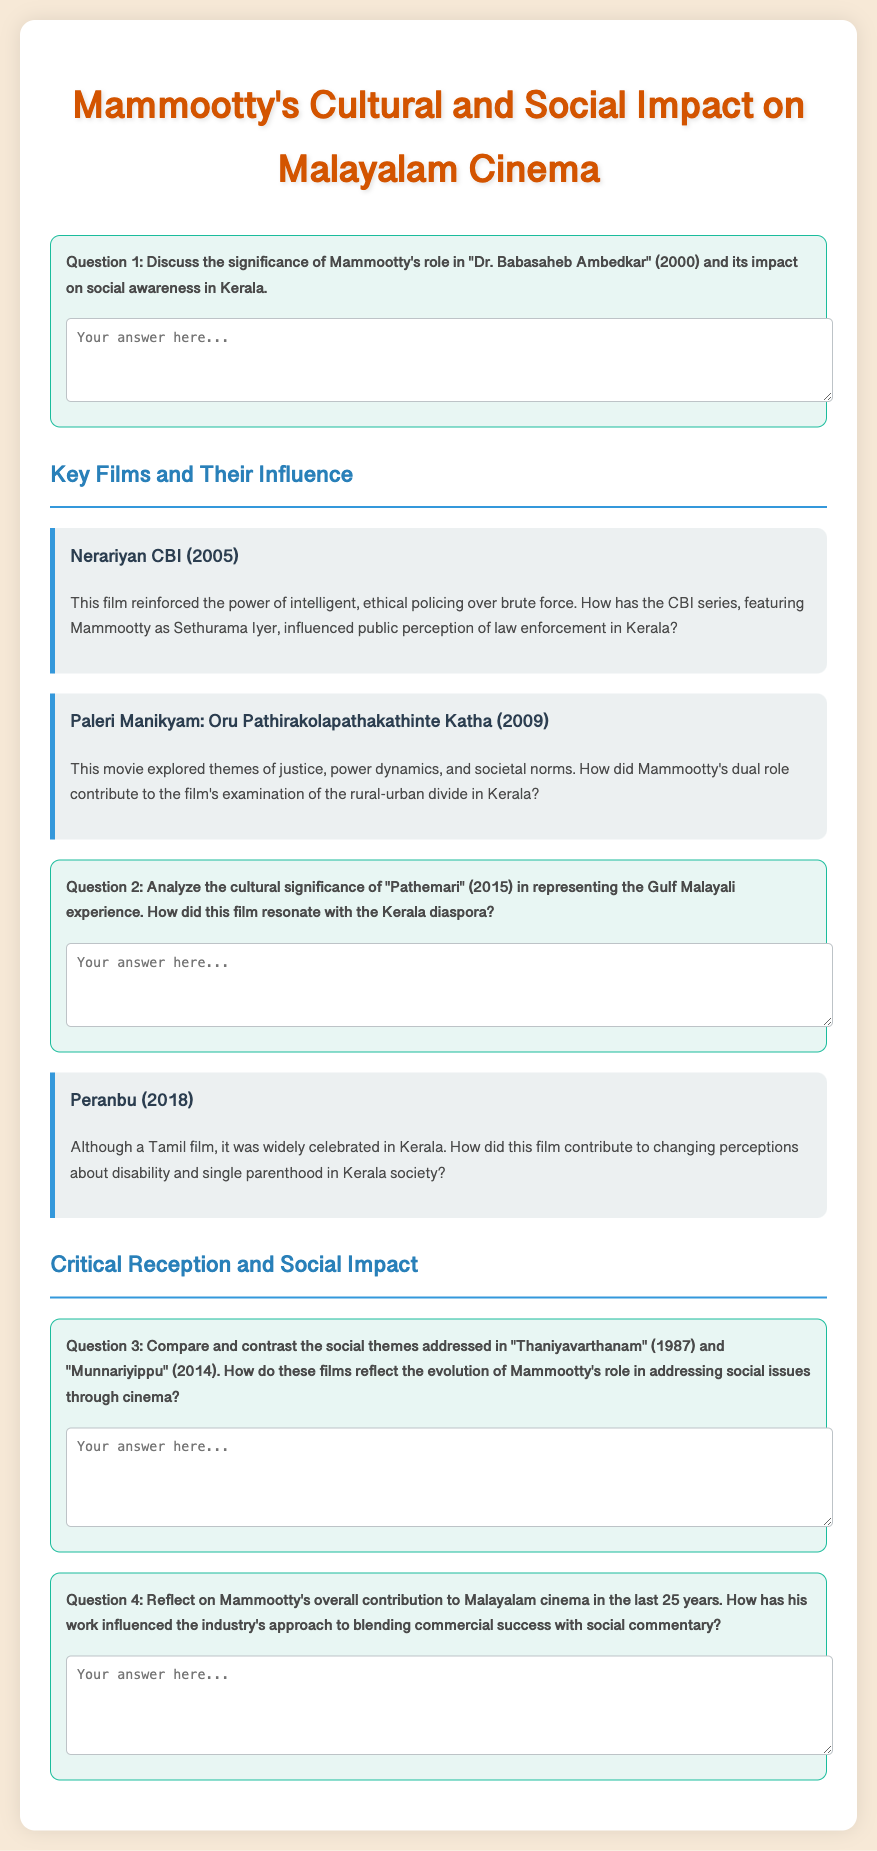What is the title of the document? The title is found at the top of the document, indicated by the <title> tag and the heading.
Answer: Mammootty's Cultural and Social Impact on Malayalam Cinema What year was "Dr. Babasaheb Ambedkar" released? The release year for this film is mentioned directly in the text.
Answer: 2000 Which character is portrayed by Mammootty in the CBI series? The character's name is specified in the description of the film "Nerariyan CBI".
Answer: Sethurama Iyer What theme is explored in "Paleri Manikyam"? The theme of this film is described in its summary.
Answer: Justice, power dynamics, and societal norms In which year was "Pathemari" released? The release year is provided in the question about the film's cultural significance.
Answer: 2015 Which film is mentioned as contributing to changing perceptions about disability? The related film is noted in its description regarding disability perceptions.
Answer: Peranbu What is the comparison focus of Question 3? The question contrasts specific films discussing social themes.
Answer: "Thaniyavarthanam" and "Munnariyippu" What is Mammootty's overall contribution to Malayalam cinema in the last 25 years? This is addressed in one of the reflective questions.
Answer: Social commentary and commercial success 